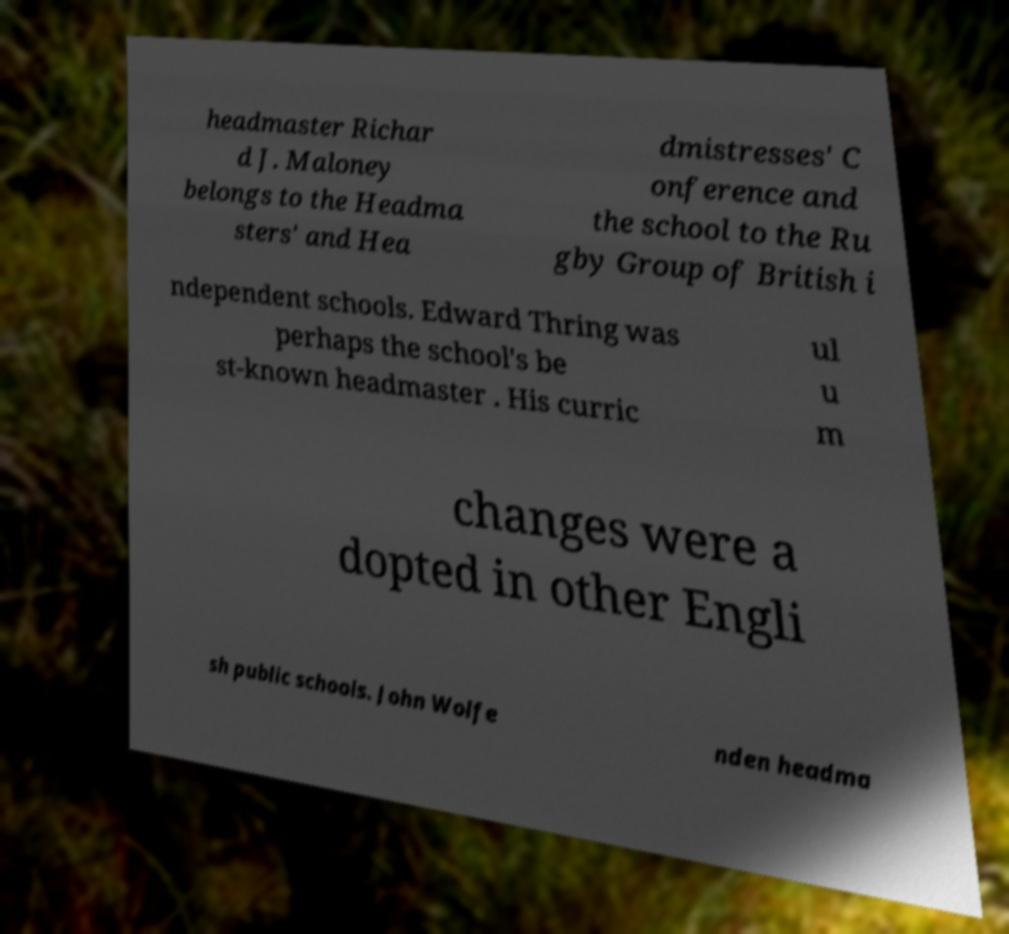Can you accurately transcribe the text from the provided image for me? headmaster Richar d J. Maloney belongs to the Headma sters' and Hea dmistresses' C onference and the school to the Ru gby Group of British i ndependent schools. Edward Thring was perhaps the school's be st-known headmaster . His curric ul u m changes were a dopted in other Engli sh public schools. John Wolfe nden headma 